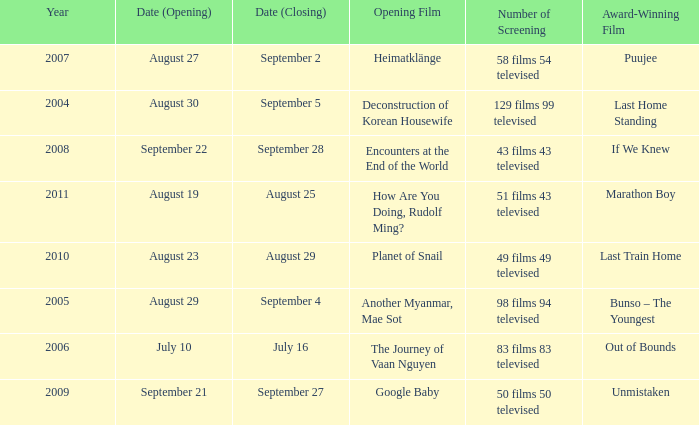Which award-winning film has a closing date of September 4? Bunso – The Youngest. 